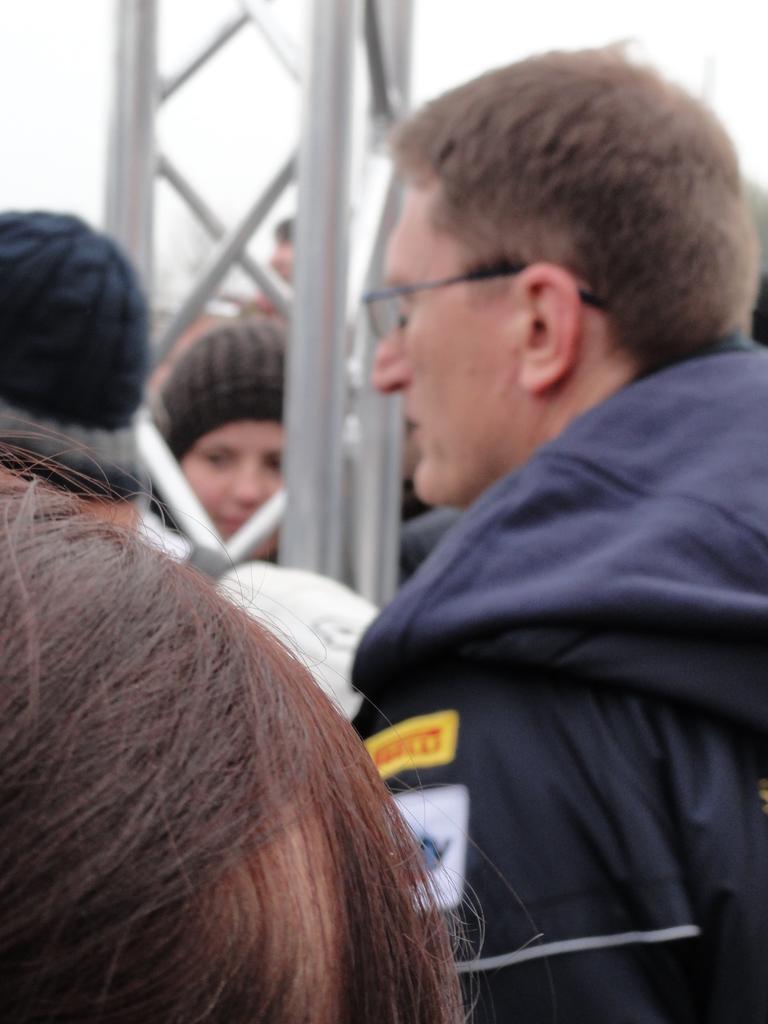Please provide a concise description of this image. There are people at the bottom of this image and there is a tower in the middle of this image. The sky is in the background. 